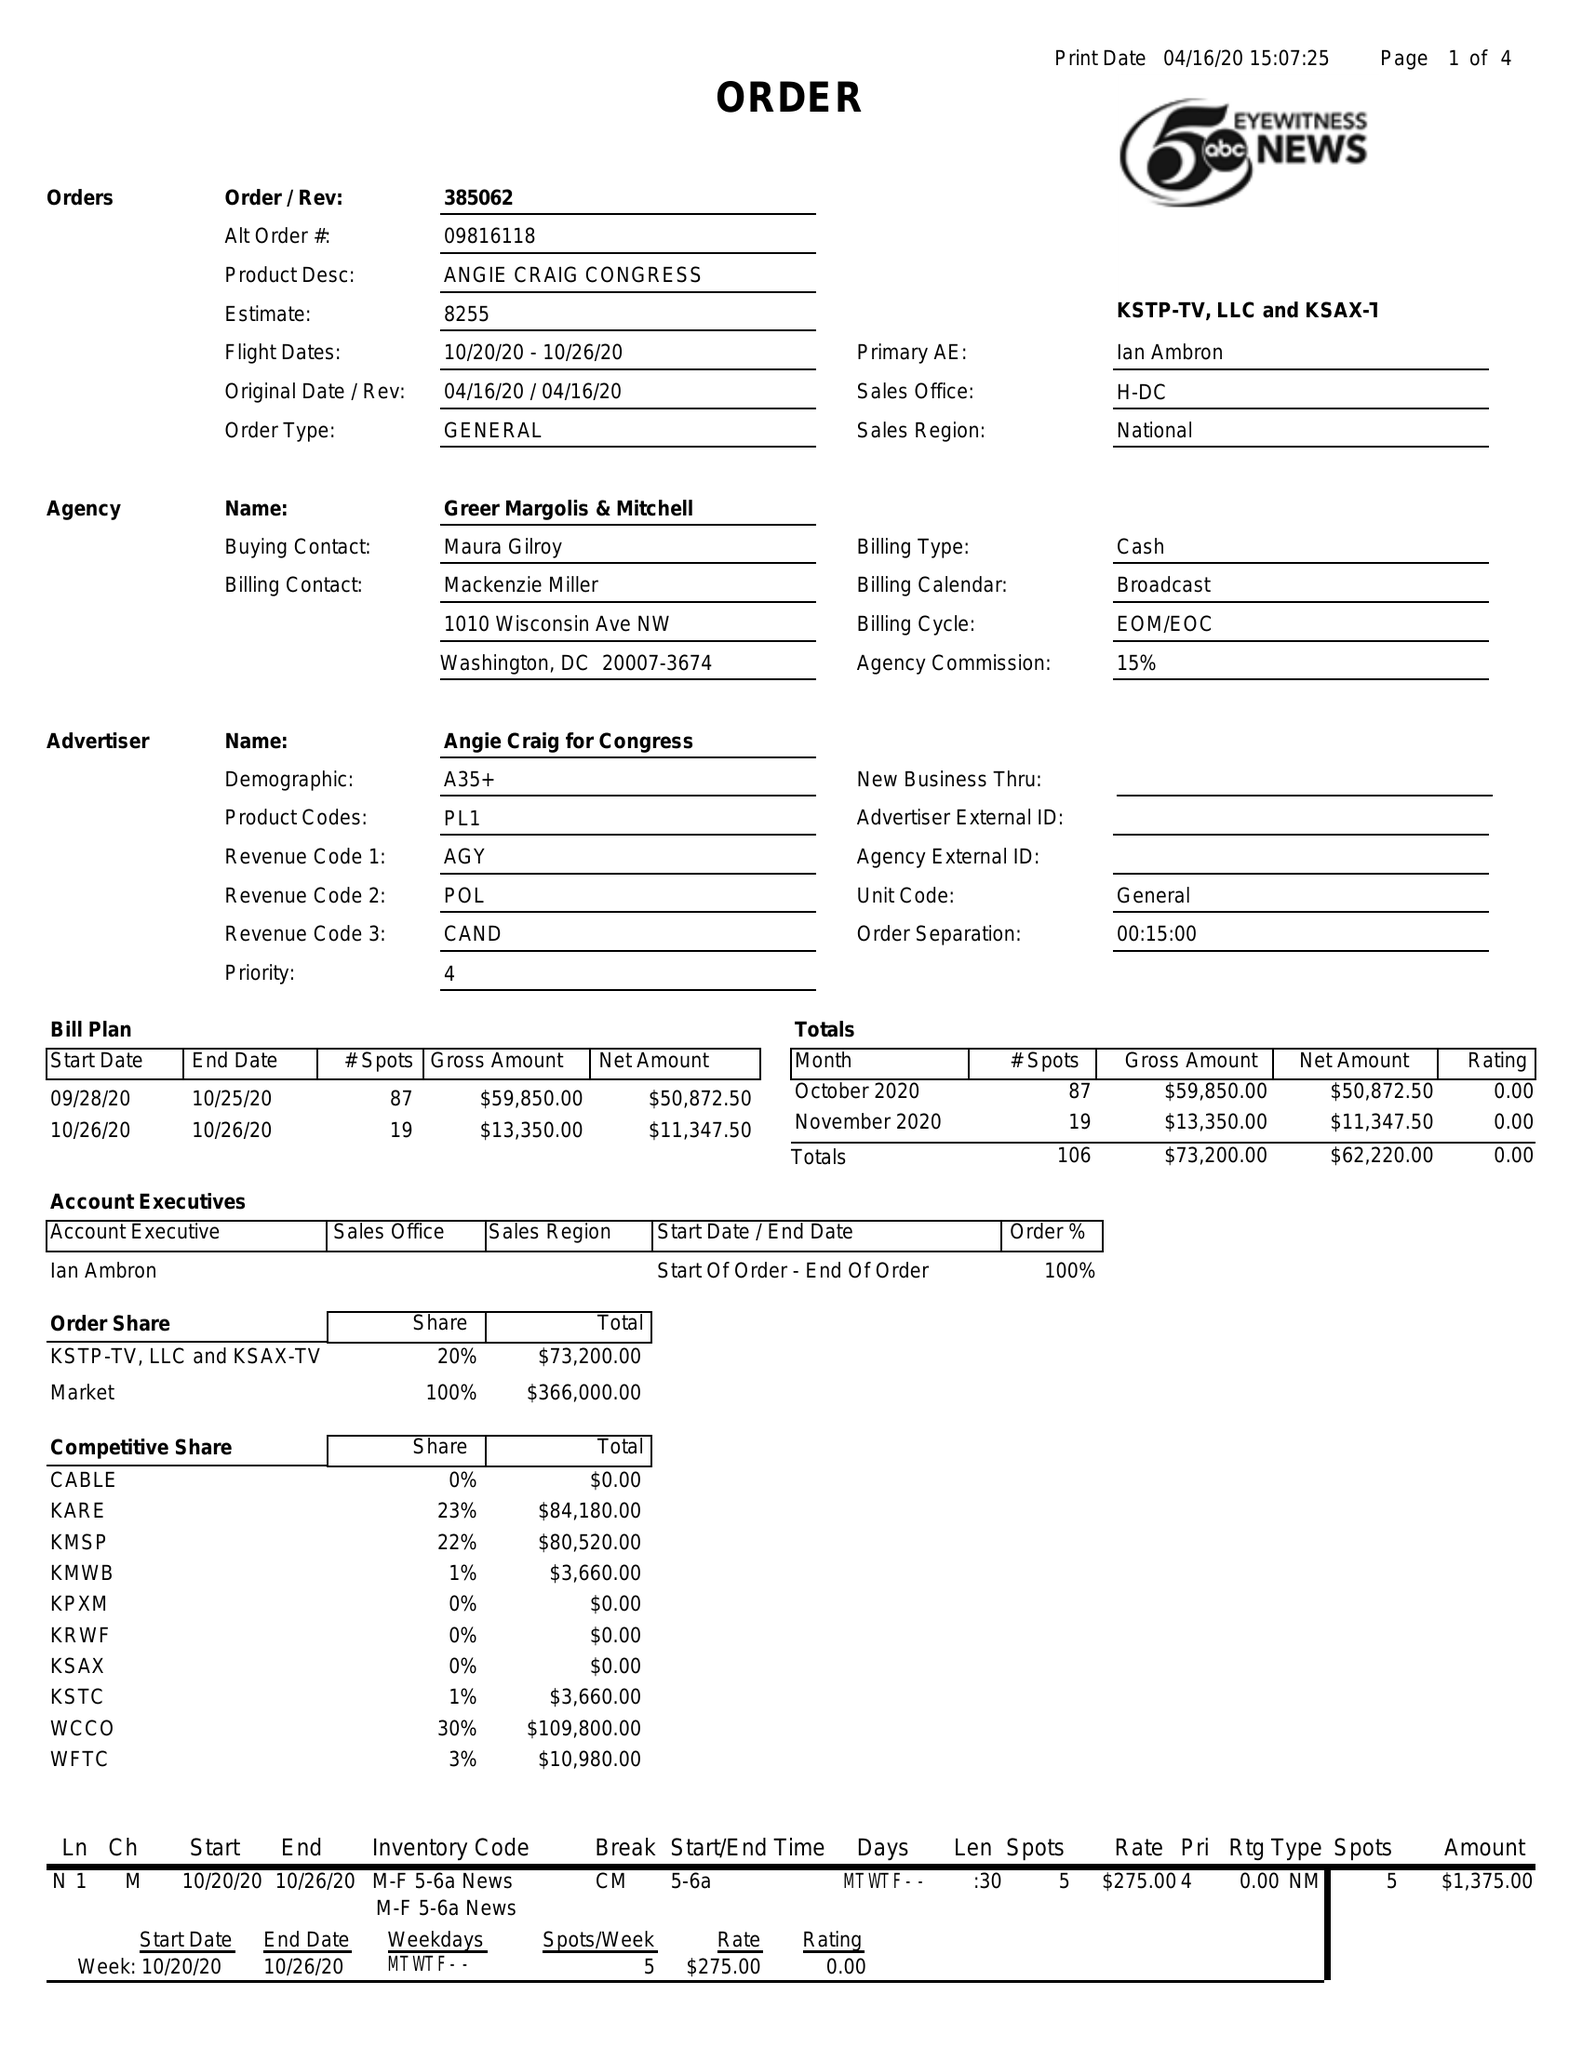What is the value for the advertiser?
Answer the question using a single word or phrase. 38506210 